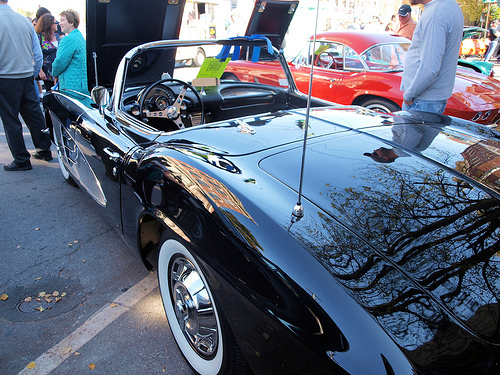<image>
Is the woman behind the car? No. The woman is not behind the car. From this viewpoint, the woman appears to be positioned elsewhere in the scene. 